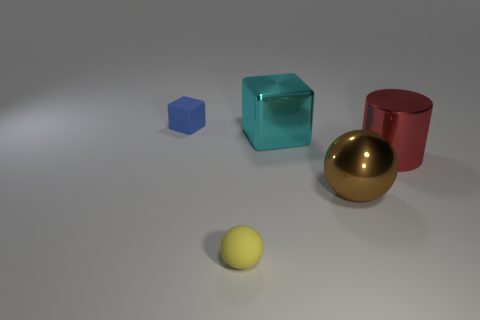How many cyan cubes are made of the same material as the cylinder?
Your response must be concise. 1. Do the yellow matte object and the shiny sphere have the same size?
Offer a very short reply. No. Are there any other things that have the same color as the large cylinder?
Provide a short and direct response. No. The object that is both in front of the big shiny cylinder and to the right of the big cyan cube has what shape?
Keep it short and to the point. Sphere. How big is the ball that is to the right of the large cyan shiny cube?
Give a very brief answer. Large. There is a block right of the tiny thing in front of the metal block; what number of big cyan metal things are behind it?
Your answer should be compact. 0. There is a big brown ball; are there any tiny matte objects in front of it?
Make the answer very short. Yes. How many other things are there of the same size as the blue rubber block?
Offer a terse response. 1. There is a thing that is both behind the brown object and to the right of the large cube; what is it made of?
Make the answer very short. Metal. Do the small rubber thing that is in front of the metal block and the shiny object that is to the left of the big brown sphere have the same shape?
Provide a succinct answer. No. 